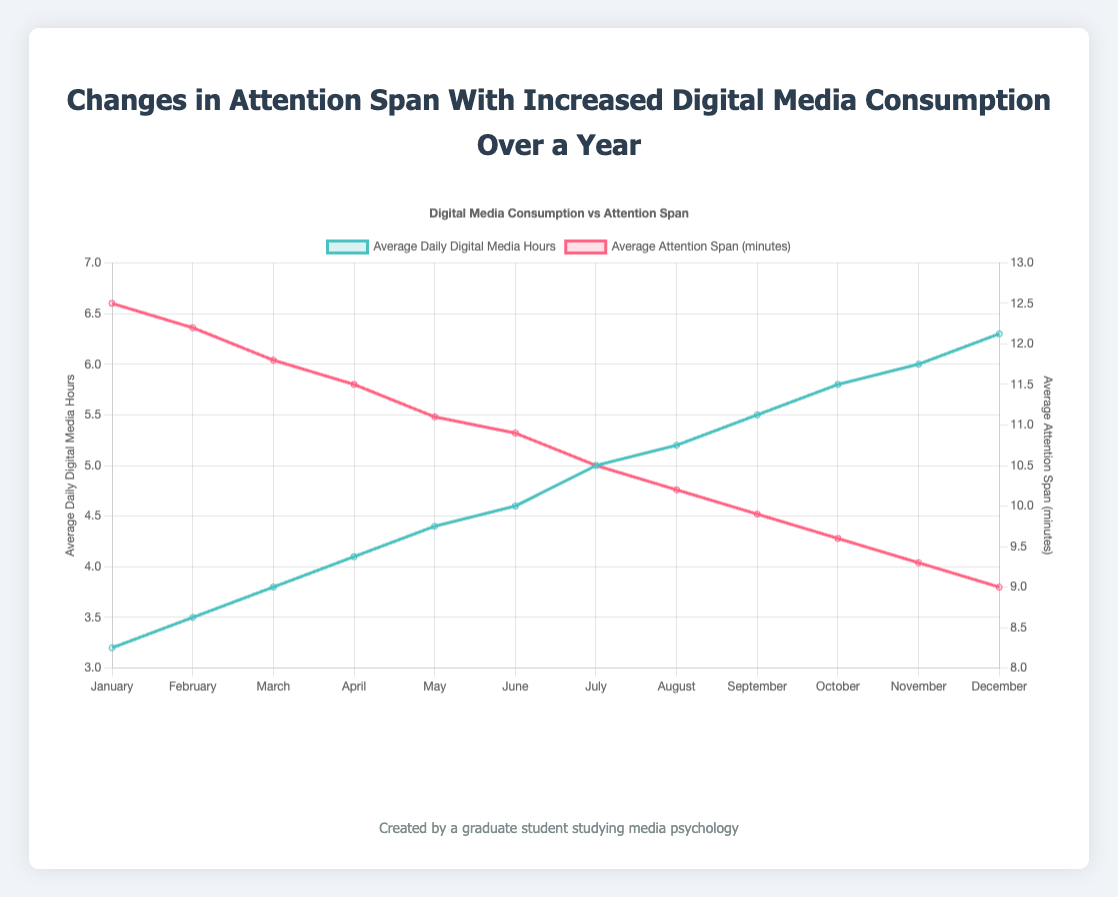What's the trend in average daily digital media hours over the months? The plot shows a steady increase in average daily digital media hours from January (3.2 hours) to December (6.3 hours). By observing the line representing digital media hours, it's clear that it slopes upward throughout the year.
Answer: Increase How does the average attention span change as average daily digital media hours increase? The average attention span tends to decrease as digital media hours increase. This is observable by comparing the two lines: as the line for digital media hours rises, the line for attention span consistently declines.
Answer: Decrease Which month had the highest average attention span, and what was it? On the plot, the highest point on the red line (representing average attention span) is in January, with an average attention span of 12.5 minutes.
Answer: January, 12.5 minutes In which month did the average daily digital media hours first exceed 5 hours? Observing the blue line in the plot, the first time it surpasses the 5-hour mark is in July.
Answer: July What's the difference in average attention span between January and December? The average attention span in January is 12.5 minutes and in December is 9.0 minutes. The difference is calculated as 12.5 - 9.0 = 3.5 minutes.
Answer: 3.5 minutes What is the average value of digital media hours in the first six months? Summing up the values for the first six months: 3.2 + 3.5 + 3.8 + 4.1 + 4.4 + 4.6 = 23.6. Dividing by 6, the average is 23.6/6 = 3.93 hours.
Answer: 3.93 hours Does the average attention span in October follow the general trend of the curve? By checking the red line, October's average attention span (9.6 minutes) follows the general decreasing trend seen throughout the year.
Answer: Yes Compare the average daily digital media hours for March and October. Which is higher and by how much? In March, the average daily digital media hours are 3.8, while in October, it is 5.8. The difference is 5.8 - 3.8 = 2.0 hours, with October being higher.
Answer: October, 2.0 hours What can you infer about the relationship between digital media consumption and attention span from the plot? The plot indicates an inverse relationship: as digital media consumption increases, the average attention span decreases, suggesting that higher digital media use might negatively impact attention span.
Answer: Inverse relationship 